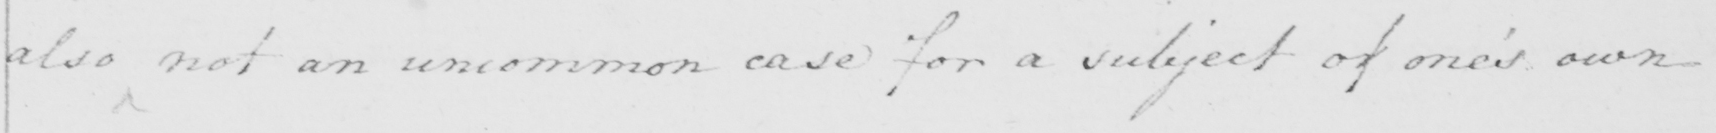Can you tell me what this handwritten text says? also not an uncommon case for a subject of one ' s own 